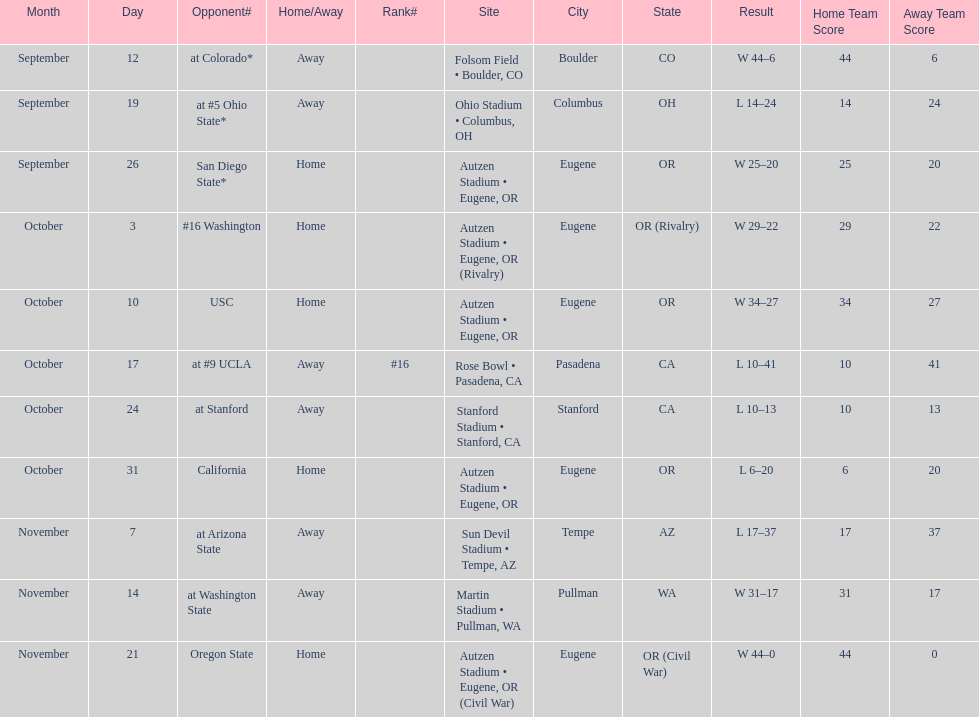How many games did the team win while not at home? 2. 